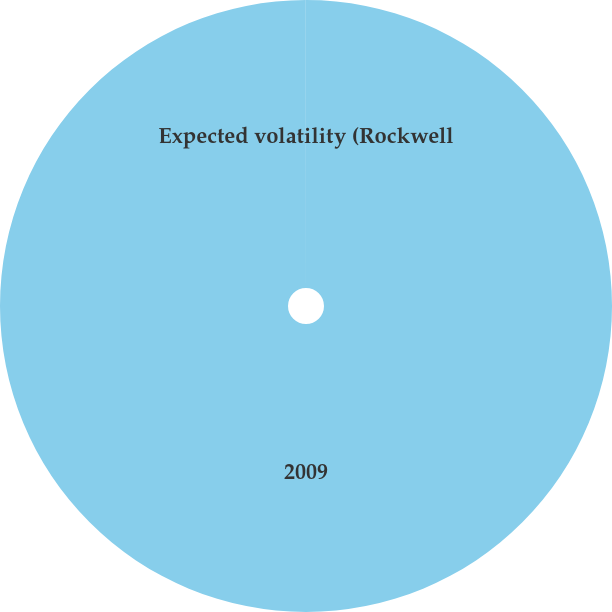Convert chart to OTSL. <chart><loc_0><loc_0><loc_500><loc_500><pie_chart><fcel>2009<fcel>Expected volatility (Rockwell<nl><fcel>99.99%<fcel>0.01%<nl></chart> 